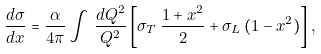<formula> <loc_0><loc_0><loc_500><loc_500>\frac { d \sigma } { d x } = \frac { \alpha } { 4 \pi } \int \, \frac { d Q ^ { 2 } } { Q ^ { 2 } } \left [ \sigma _ { T } \, \frac { 1 + x ^ { 2 } } { 2 } + \sigma _ { L } \, ( 1 - x ^ { 2 } ) \right ] ,</formula> 